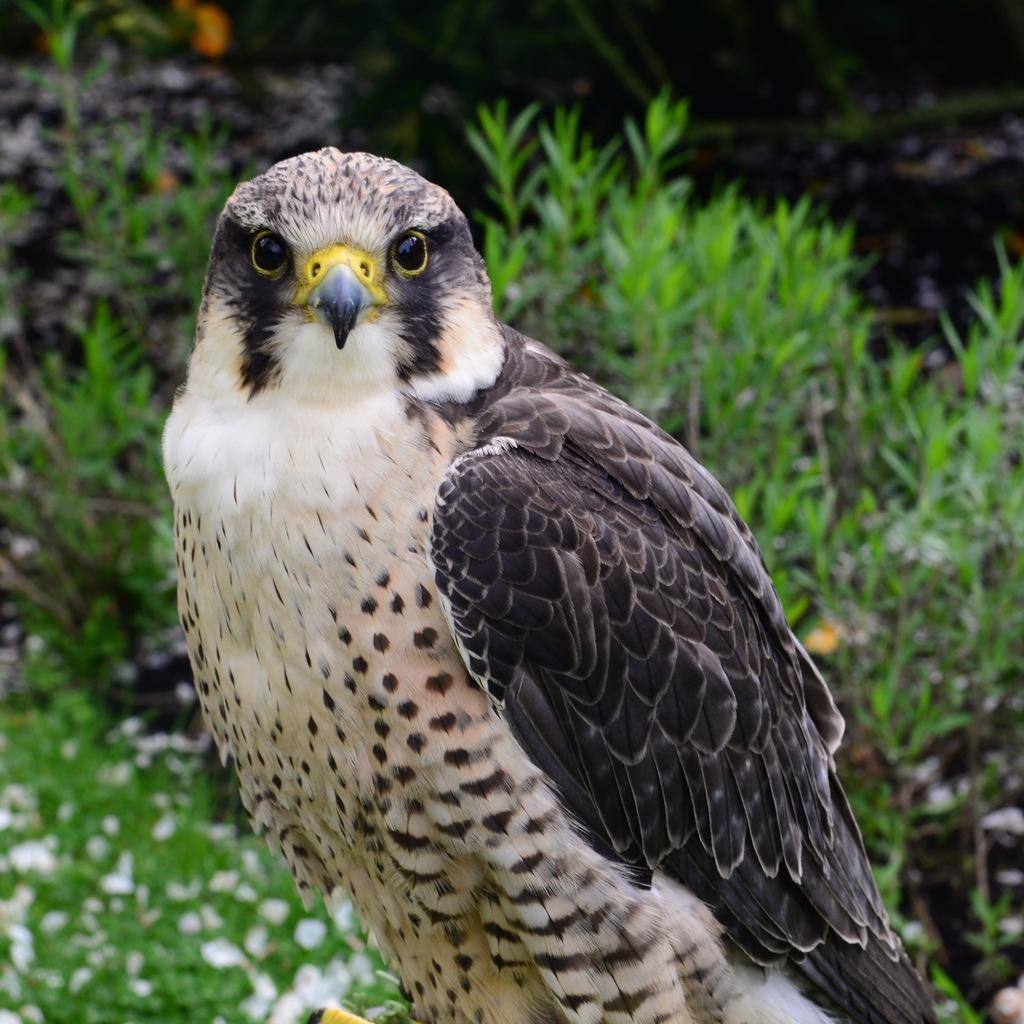What is the main subject in the foreground of the picture? There is an eagle in the foreground of the picture. How would you describe the background of the image? The background of the image is blurred. What type of vegetation can be seen in the background of the image? There are plants and flowers in the background of the image. What type of pickle is being used to water the flowers in the image? There is no pickle present in the image, and therefore no such activity can be observed. 